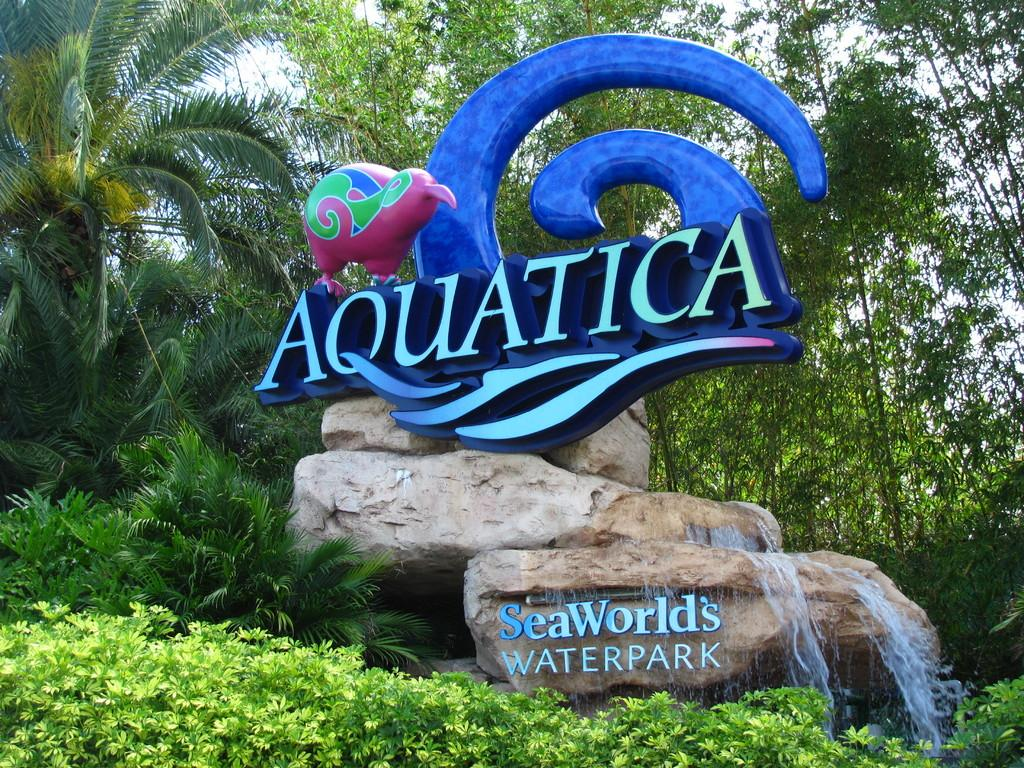What is the main subject of the image? The main subject of the image is rocks with water. Are there any words or letters visible in the image? Yes, there is writing on the rocks or water. What else can be seen in the image besides the rocks and water? There is a board with a design and name, as well as plants and trees. What is the answer to the addition problem written on the rocks in the image? There is no addition problem or answer written on the rocks in the image. --- 